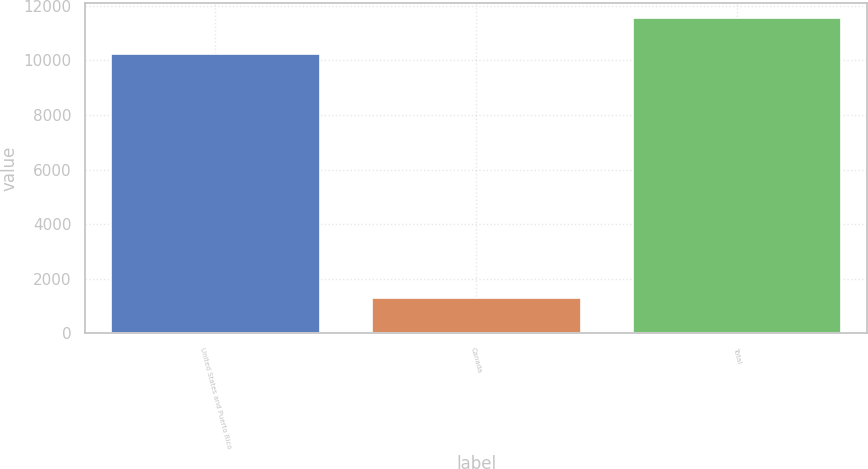<chart> <loc_0><loc_0><loc_500><loc_500><bar_chart><fcel>United States and Puerto Rico<fcel>Canada<fcel>Total<nl><fcel>10251<fcel>1290<fcel>11541<nl></chart> 